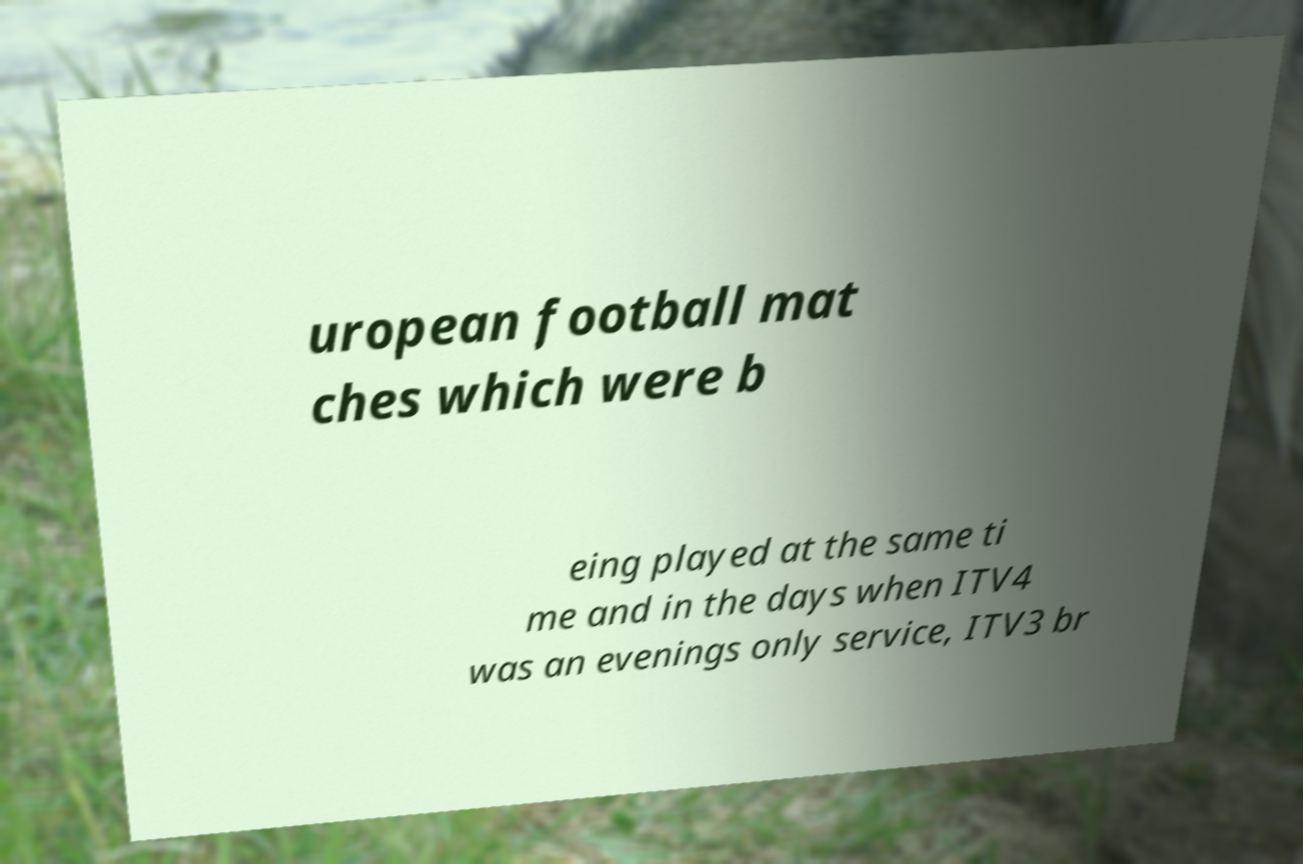There's text embedded in this image that I need extracted. Can you transcribe it verbatim? uropean football mat ches which were b eing played at the same ti me and in the days when ITV4 was an evenings only service, ITV3 br 